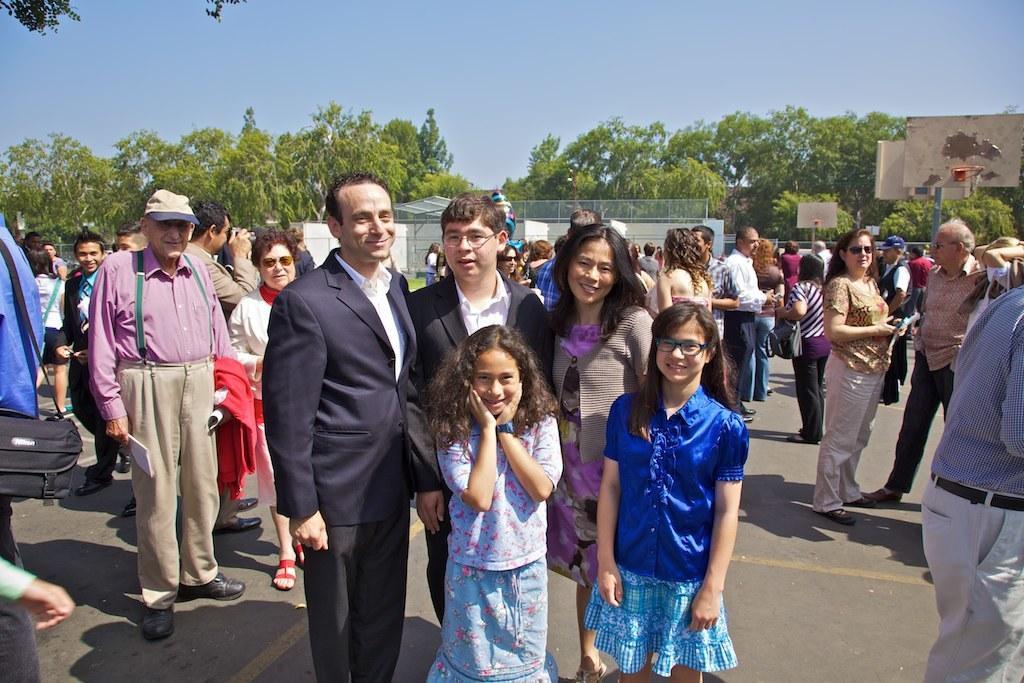Please provide a concise description of this image. This image consists of many people standing on the road. In the front, the two men are wearing black suits. At the bottom, there is a road. In the background, there are trees along with a building. To the left, the man is wearing black bag. 